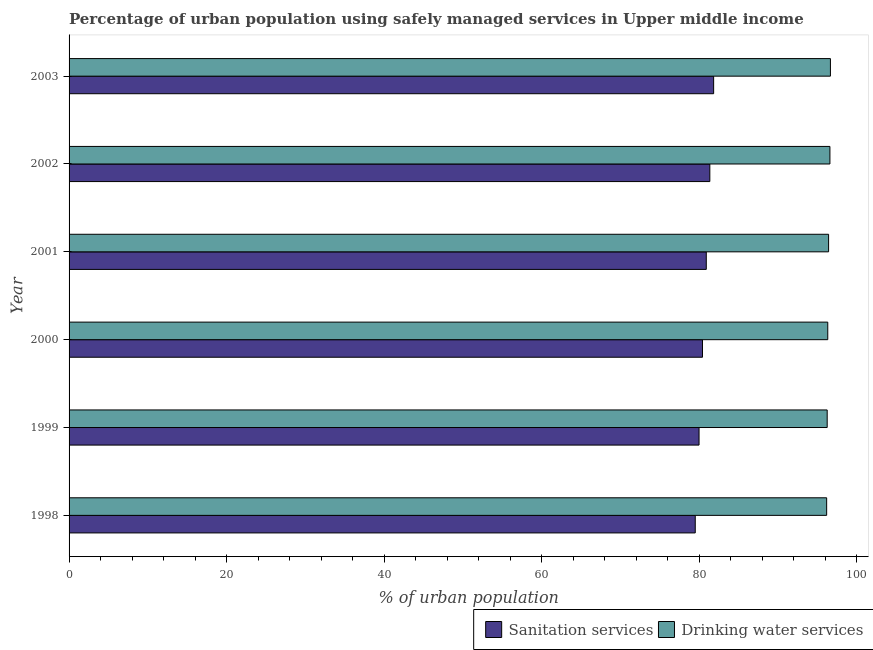How many bars are there on the 6th tick from the bottom?
Give a very brief answer. 2. In how many cases, is the number of bars for a given year not equal to the number of legend labels?
Your answer should be compact. 0. What is the percentage of urban population who used sanitation services in 1999?
Keep it short and to the point. 79.98. Across all years, what is the maximum percentage of urban population who used drinking water services?
Offer a very short reply. 96.66. Across all years, what is the minimum percentage of urban population who used sanitation services?
Keep it short and to the point. 79.5. In which year was the percentage of urban population who used sanitation services minimum?
Provide a short and direct response. 1998. What is the total percentage of urban population who used drinking water services in the graph?
Your response must be concise. 578.44. What is the difference between the percentage of urban population who used drinking water services in 1998 and that in 1999?
Ensure brevity in your answer.  -0.07. What is the difference between the percentage of urban population who used sanitation services in 1999 and the percentage of urban population who used drinking water services in 1998?
Offer a very short reply. -16.2. What is the average percentage of urban population who used drinking water services per year?
Give a very brief answer. 96.41. In the year 2001, what is the difference between the percentage of urban population who used sanitation services and percentage of urban population who used drinking water services?
Make the answer very short. -15.53. In how many years, is the percentage of urban population who used sanitation services greater than 12 %?
Your response must be concise. 6. What is the ratio of the percentage of urban population who used drinking water services in 2001 to that in 2002?
Keep it short and to the point. 1. Is the difference between the percentage of urban population who used sanitation services in 1998 and 2001 greater than the difference between the percentage of urban population who used drinking water services in 1998 and 2001?
Offer a terse response. No. What is the difference between the highest and the second highest percentage of urban population who used sanitation services?
Provide a succinct answer. 0.48. What is the difference between the highest and the lowest percentage of urban population who used drinking water services?
Give a very brief answer. 0.48. What does the 2nd bar from the top in 2002 represents?
Make the answer very short. Sanitation services. What does the 2nd bar from the bottom in 2001 represents?
Your response must be concise. Drinking water services. How many bars are there?
Give a very brief answer. 12. Are all the bars in the graph horizontal?
Your answer should be compact. Yes. What is the difference between two consecutive major ticks on the X-axis?
Provide a succinct answer. 20. Are the values on the major ticks of X-axis written in scientific E-notation?
Your answer should be compact. No. Does the graph contain any zero values?
Your response must be concise. No. Does the graph contain grids?
Provide a short and direct response. No. Where does the legend appear in the graph?
Provide a succinct answer. Bottom right. How many legend labels are there?
Your response must be concise. 2. What is the title of the graph?
Give a very brief answer. Percentage of urban population using safely managed services in Upper middle income. What is the label or title of the X-axis?
Make the answer very short. % of urban population. What is the % of urban population in Sanitation services in 1998?
Your response must be concise. 79.5. What is the % of urban population of Drinking water services in 1998?
Your answer should be very brief. 96.18. What is the % of urban population of Sanitation services in 1999?
Offer a very short reply. 79.98. What is the % of urban population in Drinking water services in 1999?
Make the answer very short. 96.25. What is the % of urban population in Sanitation services in 2000?
Make the answer very short. 80.42. What is the % of urban population in Drinking water services in 2000?
Provide a succinct answer. 96.32. What is the % of urban population in Sanitation services in 2001?
Keep it short and to the point. 80.9. What is the % of urban population in Drinking water services in 2001?
Offer a terse response. 96.43. What is the % of urban population in Sanitation services in 2002?
Give a very brief answer. 81.35. What is the % of urban population in Drinking water services in 2002?
Keep it short and to the point. 96.6. What is the % of urban population in Sanitation services in 2003?
Ensure brevity in your answer.  81.83. What is the % of urban population in Drinking water services in 2003?
Your answer should be very brief. 96.66. Across all years, what is the maximum % of urban population in Sanitation services?
Your answer should be very brief. 81.83. Across all years, what is the maximum % of urban population of Drinking water services?
Provide a short and direct response. 96.66. Across all years, what is the minimum % of urban population in Sanitation services?
Give a very brief answer. 79.5. Across all years, what is the minimum % of urban population in Drinking water services?
Provide a short and direct response. 96.18. What is the total % of urban population of Sanitation services in the graph?
Give a very brief answer. 483.98. What is the total % of urban population of Drinking water services in the graph?
Keep it short and to the point. 578.44. What is the difference between the % of urban population in Sanitation services in 1998 and that in 1999?
Your answer should be compact. -0.48. What is the difference between the % of urban population of Drinking water services in 1998 and that in 1999?
Offer a terse response. -0.07. What is the difference between the % of urban population of Sanitation services in 1998 and that in 2000?
Your answer should be very brief. -0.92. What is the difference between the % of urban population in Drinking water services in 1998 and that in 2000?
Offer a terse response. -0.14. What is the difference between the % of urban population in Sanitation services in 1998 and that in 2001?
Ensure brevity in your answer.  -1.4. What is the difference between the % of urban population of Drinking water services in 1998 and that in 2001?
Offer a very short reply. -0.24. What is the difference between the % of urban population of Sanitation services in 1998 and that in 2002?
Provide a succinct answer. -1.85. What is the difference between the % of urban population of Drinking water services in 1998 and that in 2002?
Offer a terse response. -0.41. What is the difference between the % of urban population of Sanitation services in 1998 and that in 2003?
Offer a very short reply. -2.34. What is the difference between the % of urban population of Drinking water services in 1998 and that in 2003?
Offer a terse response. -0.48. What is the difference between the % of urban population of Sanitation services in 1999 and that in 2000?
Provide a succinct answer. -0.44. What is the difference between the % of urban population in Drinking water services in 1999 and that in 2000?
Make the answer very short. -0.07. What is the difference between the % of urban population of Sanitation services in 1999 and that in 2001?
Your answer should be compact. -0.92. What is the difference between the % of urban population of Drinking water services in 1999 and that in 2001?
Provide a succinct answer. -0.18. What is the difference between the % of urban population in Sanitation services in 1999 and that in 2002?
Keep it short and to the point. -1.37. What is the difference between the % of urban population of Drinking water services in 1999 and that in 2002?
Make the answer very short. -0.35. What is the difference between the % of urban population of Sanitation services in 1999 and that in 2003?
Give a very brief answer. -1.85. What is the difference between the % of urban population of Drinking water services in 1999 and that in 2003?
Your answer should be compact. -0.41. What is the difference between the % of urban population of Sanitation services in 2000 and that in 2001?
Provide a short and direct response. -0.48. What is the difference between the % of urban population of Drinking water services in 2000 and that in 2001?
Provide a succinct answer. -0.11. What is the difference between the % of urban population of Sanitation services in 2000 and that in 2002?
Give a very brief answer. -0.93. What is the difference between the % of urban population in Drinking water services in 2000 and that in 2002?
Offer a very short reply. -0.27. What is the difference between the % of urban population in Sanitation services in 2000 and that in 2003?
Offer a terse response. -1.42. What is the difference between the % of urban population of Drinking water services in 2000 and that in 2003?
Your answer should be compact. -0.34. What is the difference between the % of urban population of Sanitation services in 2001 and that in 2002?
Give a very brief answer. -0.45. What is the difference between the % of urban population of Drinking water services in 2001 and that in 2002?
Give a very brief answer. -0.17. What is the difference between the % of urban population in Sanitation services in 2001 and that in 2003?
Ensure brevity in your answer.  -0.94. What is the difference between the % of urban population of Drinking water services in 2001 and that in 2003?
Your response must be concise. -0.23. What is the difference between the % of urban population in Sanitation services in 2002 and that in 2003?
Your answer should be compact. -0.48. What is the difference between the % of urban population of Drinking water services in 2002 and that in 2003?
Your answer should be very brief. -0.06. What is the difference between the % of urban population in Sanitation services in 1998 and the % of urban population in Drinking water services in 1999?
Your answer should be very brief. -16.75. What is the difference between the % of urban population of Sanitation services in 1998 and the % of urban population of Drinking water services in 2000?
Ensure brevity in your answer.  -16.82. What is the difference between the % of urban population of Sanitation services in 1998 and the % of urban population of Drinking water services in 2001?
Provide a succinct answer. -16.93. What is the difference between the % of urban population of Sanitation services in 1998 and the % of urban population of Drinking water services in 2002?
Your answer should be very brief. -17.1. What is the difference between the % of urban population of Sanitation services in 1998 and the % of urban population of Drinking water services in 2003?
Your response must be concise. -17.16. What is the difference between the % of urban population of Sanitation services in 1999 and the % of urban population of Drinking water services in 2000?
Offer a terse response. -16.34. What is the difference between the % of urban population in Sanitation services in 1999 and the % of urban population in Drinking water services in 2001?
Provide a short and direct response. -16.45. What is the difference between the % of urban population of Sanitation services in 1999 and the % of urban population of Drinking water services in 2002?
Your answer should be very brief. -16.61. What is the difference between the % of urban population of Sanitation services in 1999 and the % of urban population of Drinking water services in 2003?
Give a very brief answer. -16.68. What is the difference between the % of urban population of Sanitation services in 2000 and the % of urban population of Drinking water services in 2001?
Offer a terse response. -16.01. What is the difference between the % of urban population of Sanitation services in 2000 and the % of urban population of Drinking water services in 2002?
Give a very brief answer. -16.18. What is the difference between the % of urban population of Sanitation services in 2000 and the % of urban population of Drinking water services in 2003?
Your response must be concise. -16.24. What is the difference between the % of urban population in Sanitation services in 2001 and the % of urban population in Drinking water services in 2002?
Ensure brevity in your answer.  -15.7. What is the difference between the % of urban population in Sanitation services in 2001 and the % of urban population in Drinking water services in 2003?
Offer a terse response. -15.76. What is the difference between the % of urban population in Sanitation services in 2002 and the % of urban population in Drinking water services in 2003?
Provide a short and direct response. -15.31. What is the average % of urban population of Sanitation services per year?
Provide a short and direct response. 80.66. What is the average % of urban population of Drinking water services per year?
Your answer should be very brief. 96.41. In the year 1998, what is the difference between the % of urban population of Sanitation services and % of urban population of Drinking water services?
Your response must be concise. -16.69. In the year 1999, what is the difference between the % of urban population in Sanitation services and % of urban population in Drinking water services?
Give a very brief answer. -16.27. In the year 2000, what is the difference between the % of urban population in Sanitation services and % of urban population in Drinking water services?
Ensure brevity in your answer.  -15.9. In the year 2001, what is the difference between the % of urban population of Sanitation services and % of urban population of Drinking water services?
Provide a succinct answer. -15.53. In the year 2002, what is the difference between the % of urban population of Sanitation services and % of urban population of Drinking water services?
Make the answer very short. -15.25. In the year 2003, what is the difference between the % of urban population in Sanitation services and % of urban population in Drinking water services?
Provide a succinct answer. -14.83. What is the ratio of the % of urban population in Drinking water services in 1998 to that in 1999?
Provide a short and direct response. 1. What is the ratio of the % of urban population of Drinking water services in 1998 to that in 2000?
Provide a short and direct response. 1. What is the ratio of the % of urban population in Sanitation services in 1998 to that in 2001?
Your answer should be very brief. 0.98. What is the ratio of the % of urban population of Drinking water services in 1998 to that in 2001?
Give a very brief answer. 1. What is the ratio of the % of urban population of Sanitation services in 1998 to that in 2002?
Keep it short and to the point. 0.98. What is the ratio of the % of urban population in Drinking water services in 1998 to that in 2002?
Your answer should be very brief. 1. What is the ratio of the % of urban population of Sanitation services in 1998 to that in 2003?
Ensure brevity in your answer.  0.97. What is the ratio of the % of urban population of Drinking water services in 1998 to that in 2003?
Keep it short and to the point. 1. What is the ratio of the % of urban population in Drinking water services in 1999 to that in 2000?
Your answer should be very brief. 1. What is the ratio of the % of urban population in Sanitation services in 1999 to that in 2001?
Provide a succinct answer. 0.99. What is the ratio of the % of urban population in Drinking water services in 1999 to that in 2001?
Offer a very short reply. 1. What is the ratio of the % of urban population in Sanitation services in 1999 to that in 2002?
Make the answer very short. 0.98. What is the ratio of the % of urban population in Drinking water services in 1999 to that in 2002?
Give a very brief answer. 1. What is the ratio of the % of urban population of Sanitation services in 1999 to that in 2003?
Offer a very short reply. 0.98. What is the ratio of the % of urban population of Drinking water services in 1999 to that in 2003?
Provide a succinct answer. 1. What is the ratio of the % of urban population in Sanitation services in 2000 to that in 2001?
Give a very brief answer. 0.99. What is the ratio of the % of urban population of Sanitation services in 2000 to that in 2002?
Offer a very short reply. 0.99. What is the ratio of the % of urban population of Drinking water services in 2000 to that in 2002?
Provide a succinct answer. 1. What is the ratio of the % of urban population of Sanitation services in 2000 to that in 2003?
Your answer should be compact. 0.98. What is the ratio of the % of urban population in Sanitation services in 2001 to that in 2002?
Offer a terse response. 0.99. What is the ratio of the % of urban population in Drinking water services in 2001 to that in 2002?
Offer a terse response. 1. What is the ratio of the % of urban population of Drinking water services in 2002 to that in 2003?
Your answer should be compact. 1. What is the difference between the highest and the second highest % of urban population of Sanitation services?
Provide a short and direct response. 0.48. What is the difference between the highest and the second highest % of urban population of Drinking water services?
Keep it short and to the point. 0.06. What is the difference between the highest and the lowest % of urban population in Sanitation services?
Give a very brief answer. 2.34. What is the difference between the highest and the lowest % of urban population in Drinking water services?
Provide a short and direct response. 0.48. 